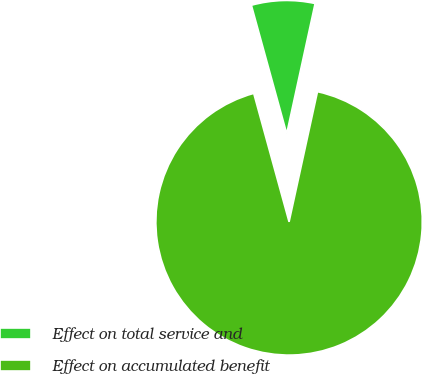Convert chart. <chart><loc_0><loc_0><loc_500><loc_500><pie_chart><fcel>Effect on total service and<fcel>Effect on accumulated benefit<nl><fcel>7.69%<fcel>92.31%<nl></chart> 